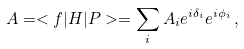<formula> <loc_0><loc_0><loc_500><loc_500>A = < f | H | P > = \sum _ { i } A _ { i } e ^ { i \delta _ { i } } e ^ { i \phi _ { i } } \, ,</formula> 